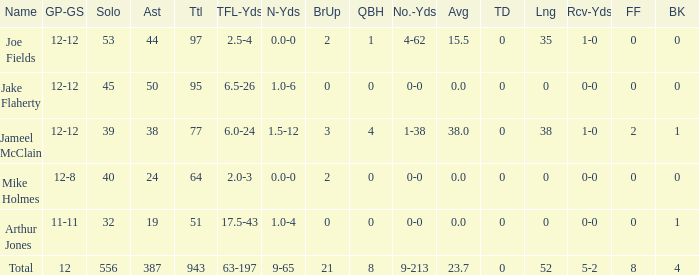How many tackle assists for the player who averages 23.7? 387.0. 